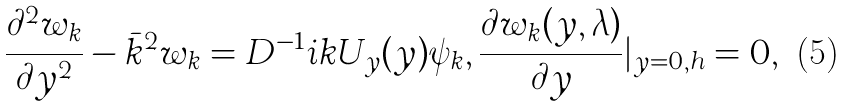<formula> <loc_0><loc_0><loc_500><loc_500>\frac { \partial ^ { 2 } w _ { k } } { \partial y ^ { 2 } } - \bar { k } ^ { 2 } w _ { k } = D ^ { - 1 } i k U _ { y } ( y ) \psi _ { k } , \frac { \partial w _ { k } ( y , \lambda ) } { \partial y } | _ { y = 0 , h } = 0 ,</formula> 